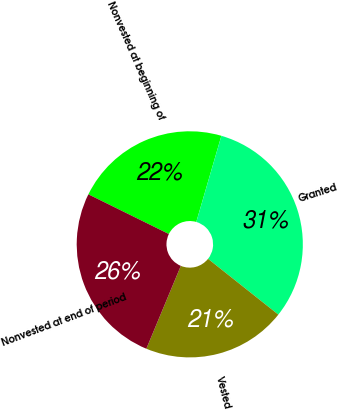Convert chart to OTSL. <chart><loc_0><loc_0><loc_500><loc_500><pie_chart><fcel>Nonvested at beginning of<fcel>Granted<fcel>Vested<fcel>Nonvested at end of period<nl><fcel>22.22%<fcel>31.17%<fcel>20.6%<fcel>26.02%<nl></chart> 